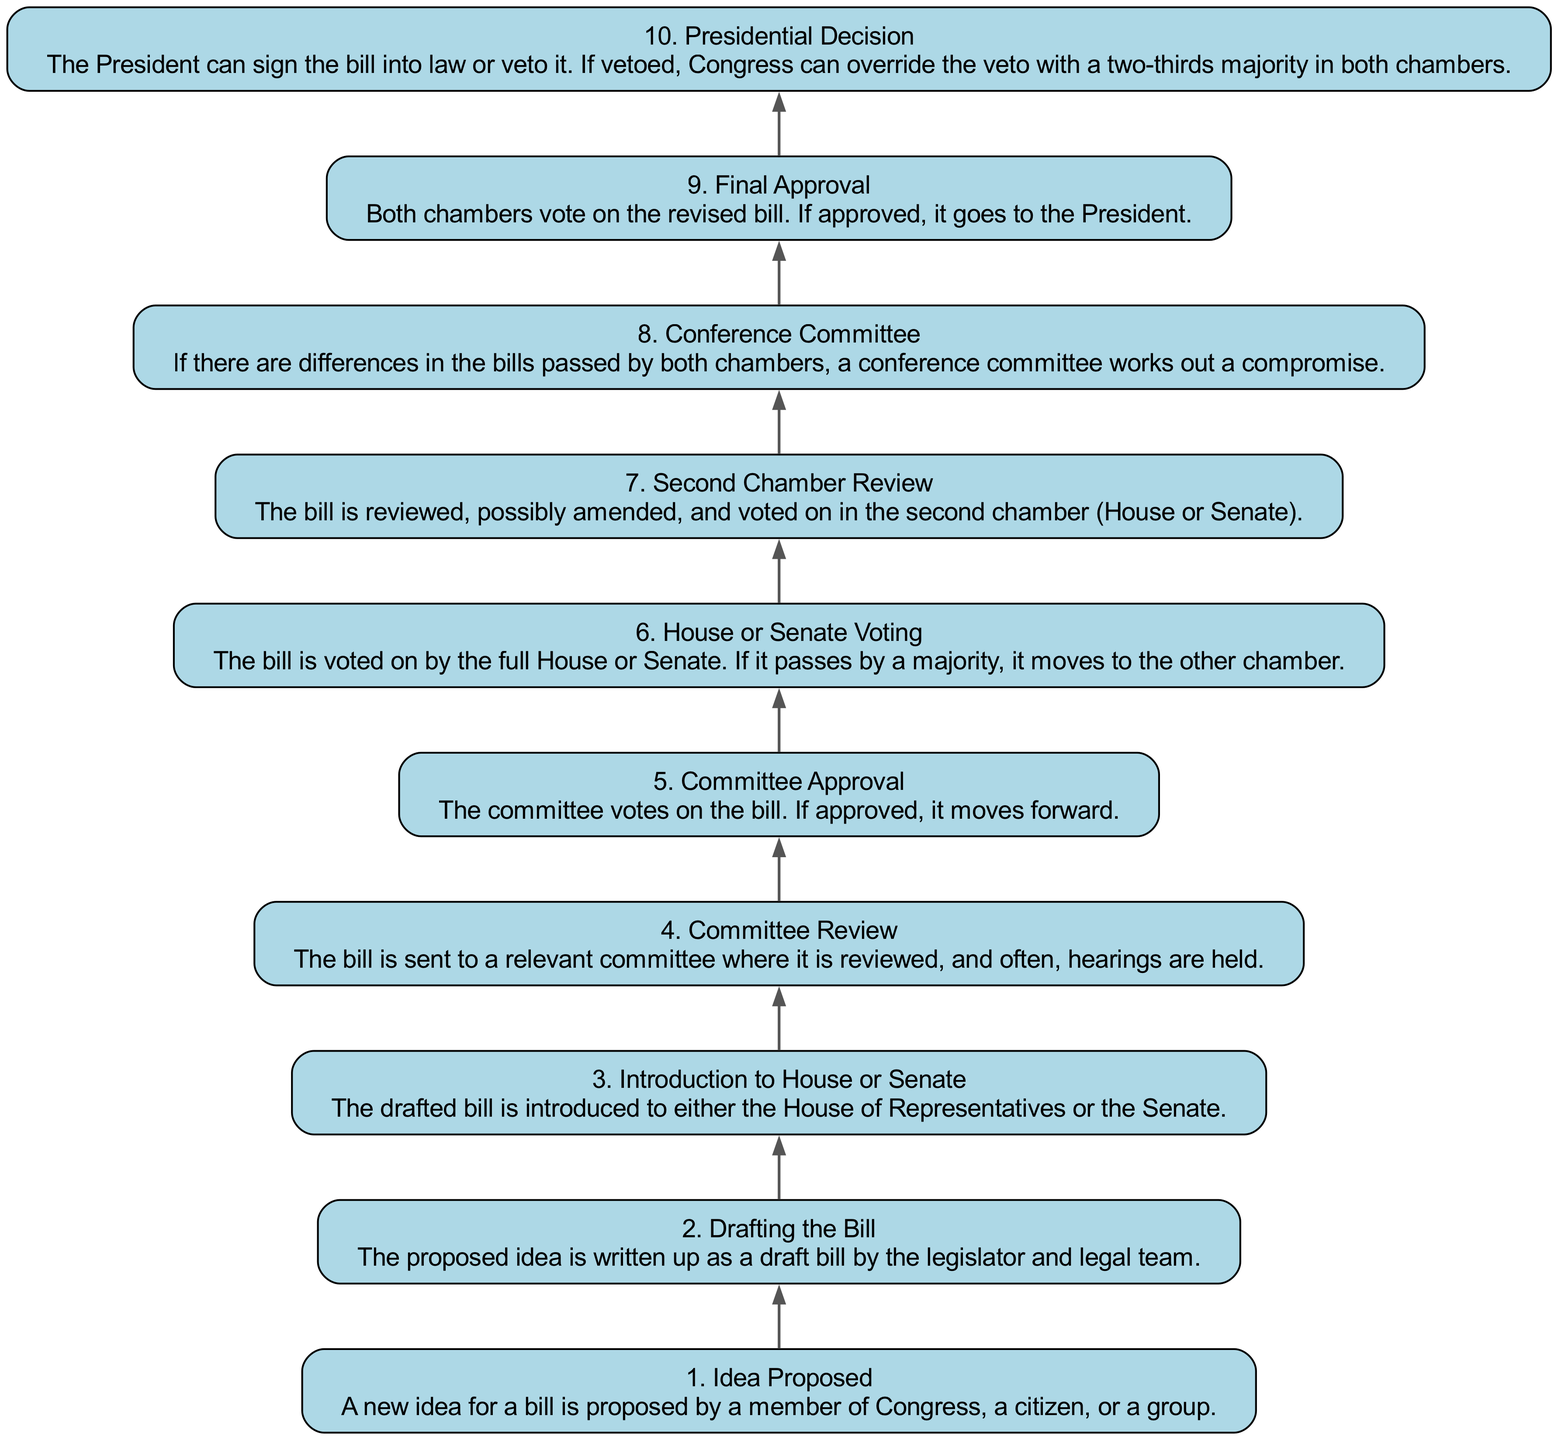What is the first step in the process? The diagram starts with "1. Idea Proposed," which indicates that the first action is the proposal of a new idea for a bill.
Answer: Idea Proposed How many steps are there in total in the diagram? The diagram lists ten distinct steps numbered from one to ten, detailing each part of the legislative process.
Answer: 10 Which step comes after "Presidential Decision"? There are no steps after "10. Presidential Decision," as it is the final step in the legislative process as shown in the diagram.
Answer: None What is the description of step 5? Step 5 is "Committee Approval," which involves the committee voting on the bill, and if approved, it moves forward in the process.
Answer: The committee votes on the bill. If approved, it moves forward Which two steps are connected directly by an edge before reaching "Final Approval"? The steps "Second Chamber Review" and "Final Approval" are connected directly, indicating that after reviewing and possibly amending the bill, it progresses to final voting.
Answer: Second Chamber Review and Final Approval What action follows "Committee Review"? After "4. Committee Review," the next action is "5. Committee Approval," where the committee votes on the proposed bill.
Answer: Committee Approval If a bill is vetoed by the President, what can Congress do next? According to step 10's description regarding presidential decision, Congress can override the veto with a two-thirds majority in both chambers if a bill is vetoed.
Answer: Override the veto What happens during the "Conference Committee" step? During the "8. Conference Committee" step, a conference committee works out a compromise if there are differences in the bills that passed in both chambers.
Answer: A conference committee works out a compromise Which step involves voting by the full House or Senate? The step "6. House or Senate Voting" is where the full House or Senate votes on the bill, determining if it will move forward.
Answer: House or Senate Voting 